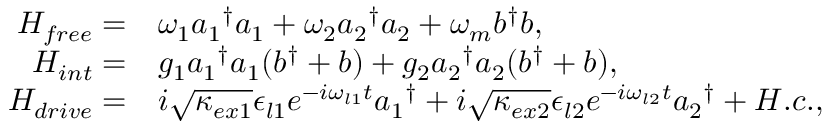Convert formula to latex. <formula><loc_0><loc_0><loc_500><loc_500>\begin{array} { r l } { H _ { f r e e } = } & { \omega _ { 1 } { a _ { 1 } } ^ { \dagger } a _ { 1 } + \omega _ { 2 } { a _ { 2 } } ^ { \dagger } a _ { 2 } + \omega _ { m } b ^ { \dagger } b , } \\ { H _ { i n t } = } & { g _ { 1 } { a _ { 1 } } ^ { \dagger } a _ { 1 } ( b ^ { \dagger } + b ) + g _ { 2 } { a _ { 2 } } ^ { \dagger } a _ { 2 } ( b ^ { \dagger } + b ) , } \\ { H _ { d r i v e } = } & { i \sqrt { \kappa _ { e x 1 } } \epsilon _ { l 1 } e ^ { - i \omega _ { l 1 } t } { a _ { 1 } } ^ { \dagger } + i \sqrt { \kappa _ { e x 2 } } \epsilon _ { l 2 } e ^ { - i \omega _ { l 2 } t } { a _ { 2 } } ^ { \dagger } + H . c . , } \end{array}</formula> 